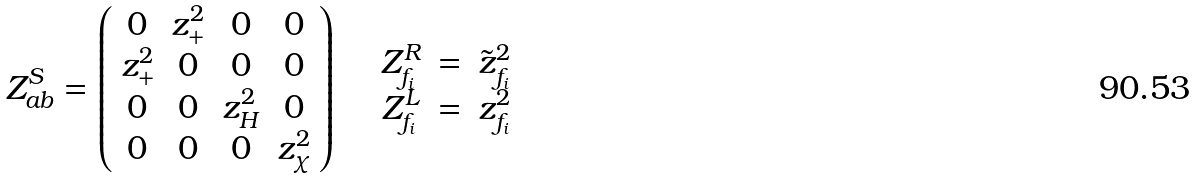Convert formula to latex. <formula><loc_0><loc_0><loc_500><loc_500>Z ^ { S } _ { a b } = \left ( \begin{array} { c c c c } 0 & z _ { + } ^ { 2 } & 0 & 0 \\ z _ { + } ^ { 2 } & 0 & 0 & 0 \\ 0 & 0 & z _ { H } ^ { 2 } & 0 \\ 0 & 0 & 0 & z ^ { 2 } _ { \chi } \end{array} \right ) \quad \begin{array} { c c c } Z ^ { R } _ { f _ { i } } & = & \tilde { z } _ { f _ { i } } ^ { 2 } \\ Z ^ { L } _ { f _ { i } } & = & z _ { f _ { i } } ^ { 2 } \end{array}</formula> 